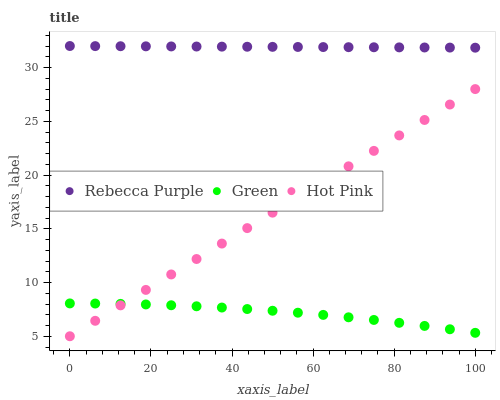Does Green have the minimum area under the curve?
Answer yes or no. Yes. Does Rebecca Purple have the maximum area under the curve?
Answer yes or no. Yes. Does Rebecca Purple have the minimum area under the curve?
Answer yes or no. No. Does Green have the maximum area under the curve?
Answer yes or no. No. Is Rebecca Purple the smoothest?
Answer yes or no. Yes. Is Green the roughest?
Answer yes or no. Yes. Is Green the smoothest?
Answer yes or no. No. Is Rebecca Purple the roughest?
Answer yes or no. No. Does Hot Pink have the lowest value?
Answer yes or no. Yes. Does Green have the lowest value?
Answer yes or no. No. Does Rebecca Purple have the highest value?
Answer yes or no. Yes. Does Green have the highest value?
Answer yes or no. No. Is Hot Pink less than Rebecca Purple?
Answer yes or no. Yes. Is Rebecca Purple greater than Hot Pink?
Answer yes or no. Yes. Does Green intersect Hot Pink?
Answer yes or no. Yes. Is Green less than Hot Pink?
Answer yes or no. No. Is Green greater than Hot Pink?
Answer yes or no. No. Does Hot Pink intersect Rebecca Purple?
Answer yes or no. No. 